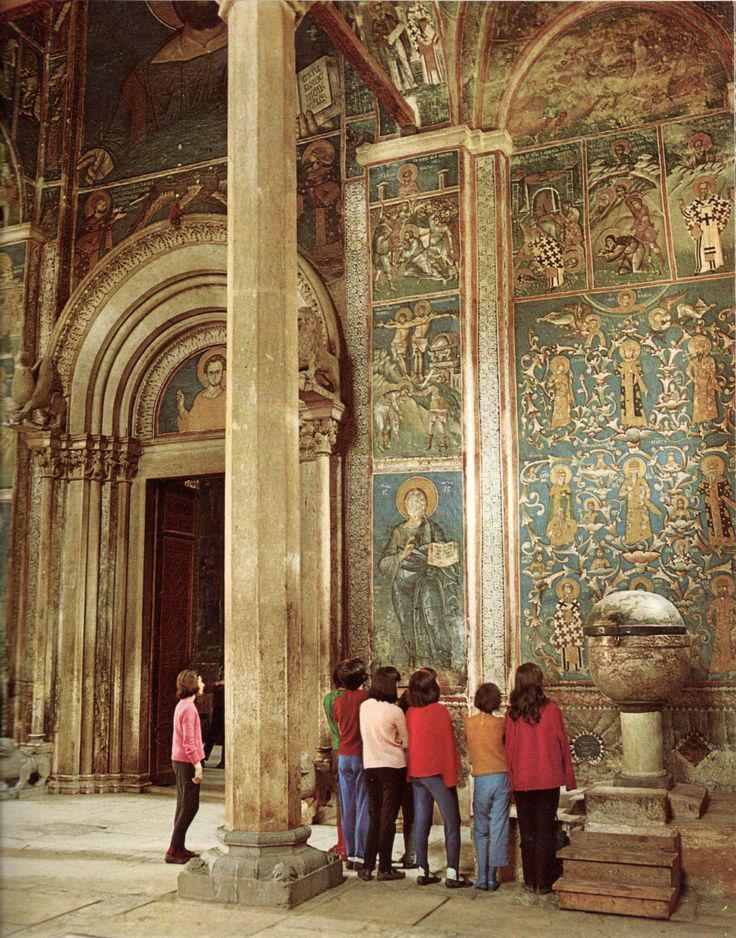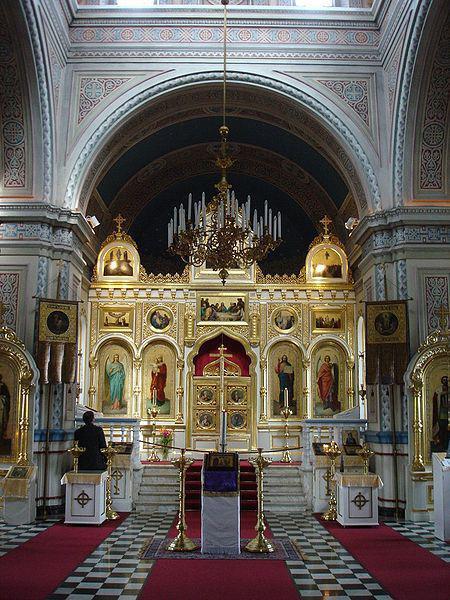The first image is the image on the left, the second image is the image on the right. Given the left and right images, does the statement "There is a person in the image on the left." hold true? Answer yes or no. Yes. The first image is the image on the left, the second image is the image on the right. For the images shown, is this caption "Clear arch-topped windows are featured in at least one image." true? Answer yes or no. No. 